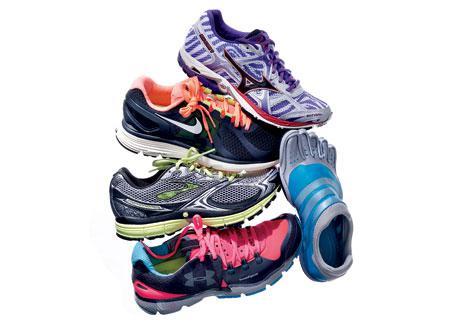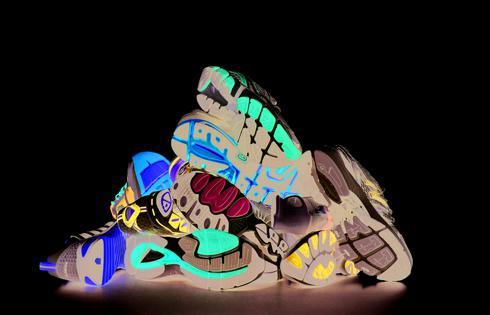The first image is the image on the left, the second image is the image on the right. For the images shown, is this caption "In one image only the tops and sides of the shoes are visible." true? Answer yes or no. Yes. The first image is the image on the left, the second image is the image on the right. Considering the images on both sides, is "At least one of the images prominently displays one or more Nike brand shoe with the brand's signature """"swoosh"""" logo on the side." valid? Answer yes or no. Yes. 